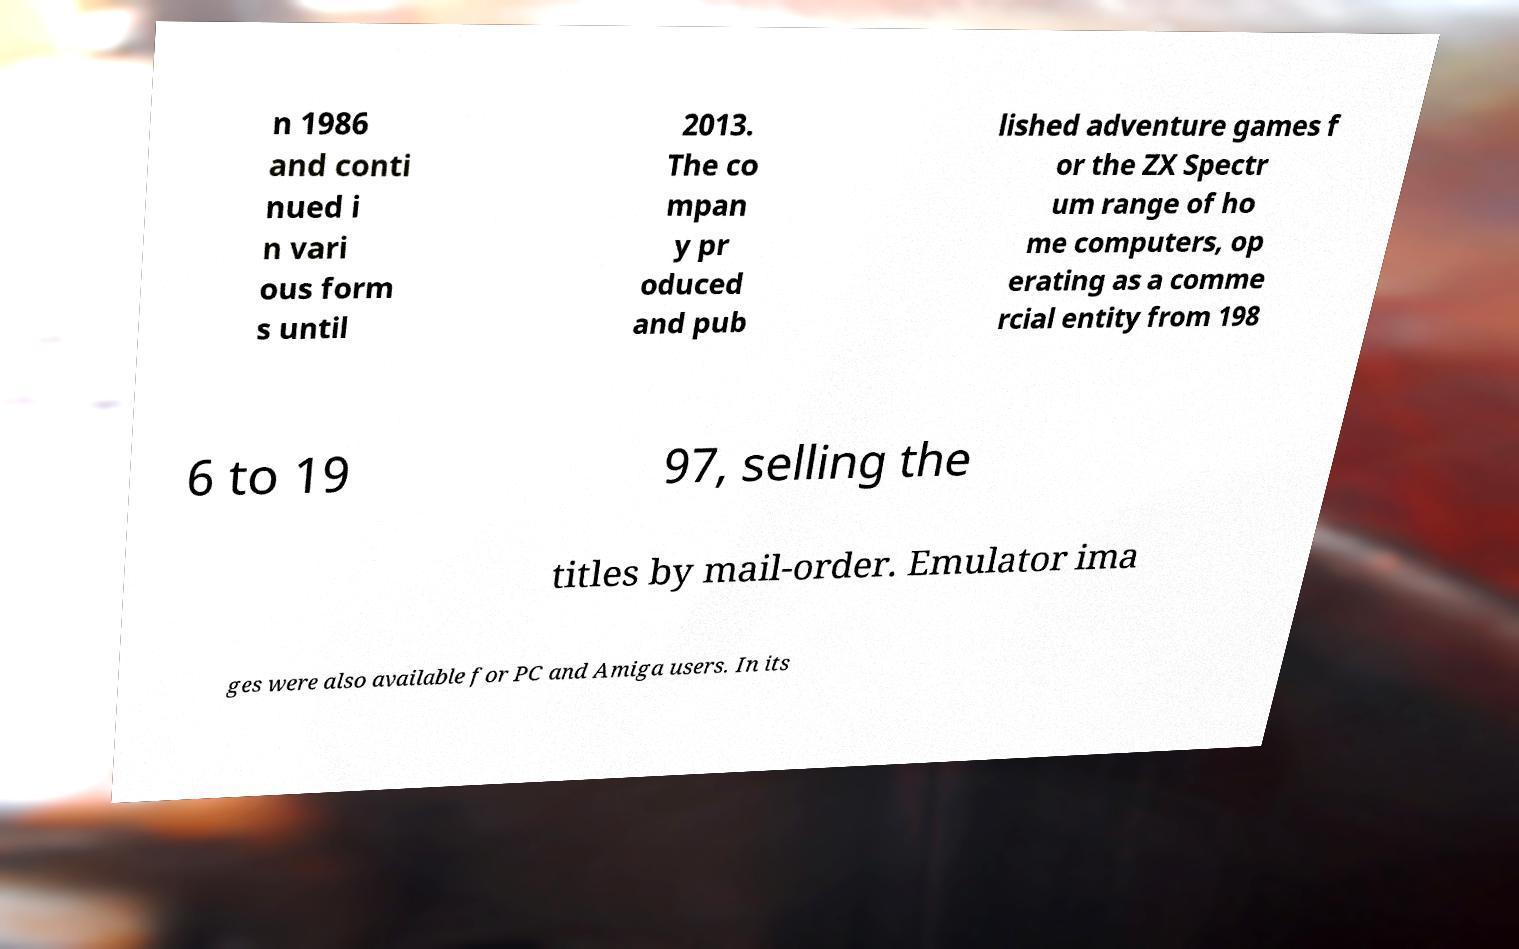Please read and relay the text visible in this image. What does it say? n 1986 and conti nued i n vari ous form s until 2013. The co mpan y pr oduced and pub lished adventure games f or the ZX Spectr um range of ho me computers, op erating as a comme rcial entity from 198 6 to 19 97, selling the titles by mail-order. Emulator ima ges were also available for PC and Amiga users. In its 